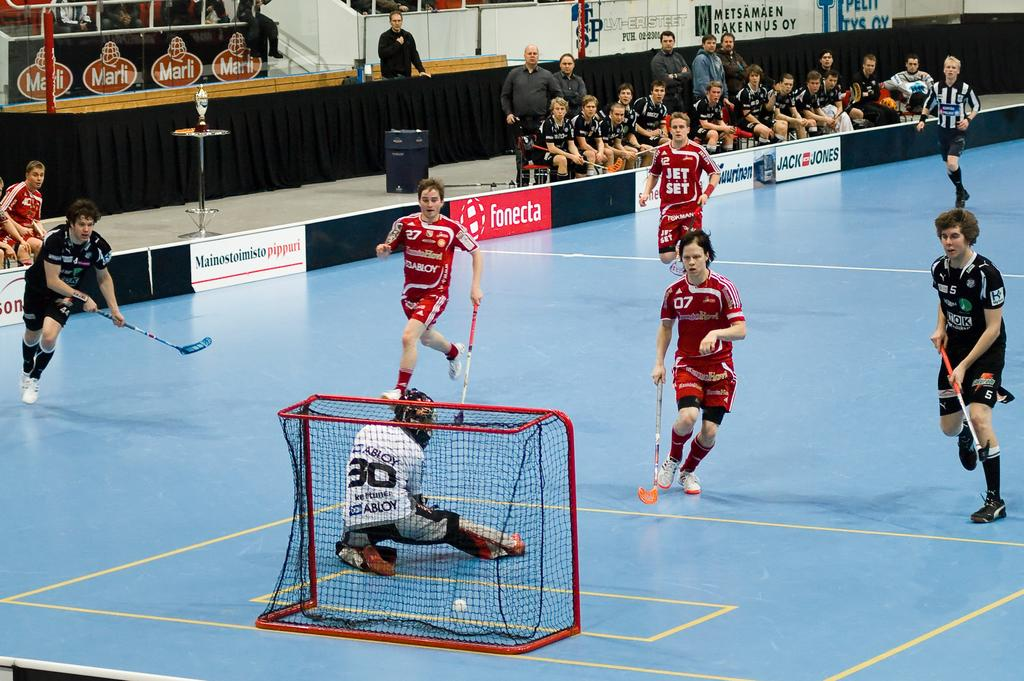<image>
Describe the image concisely. Player number 30 in white watches as a ball passes through the net for a goal. 